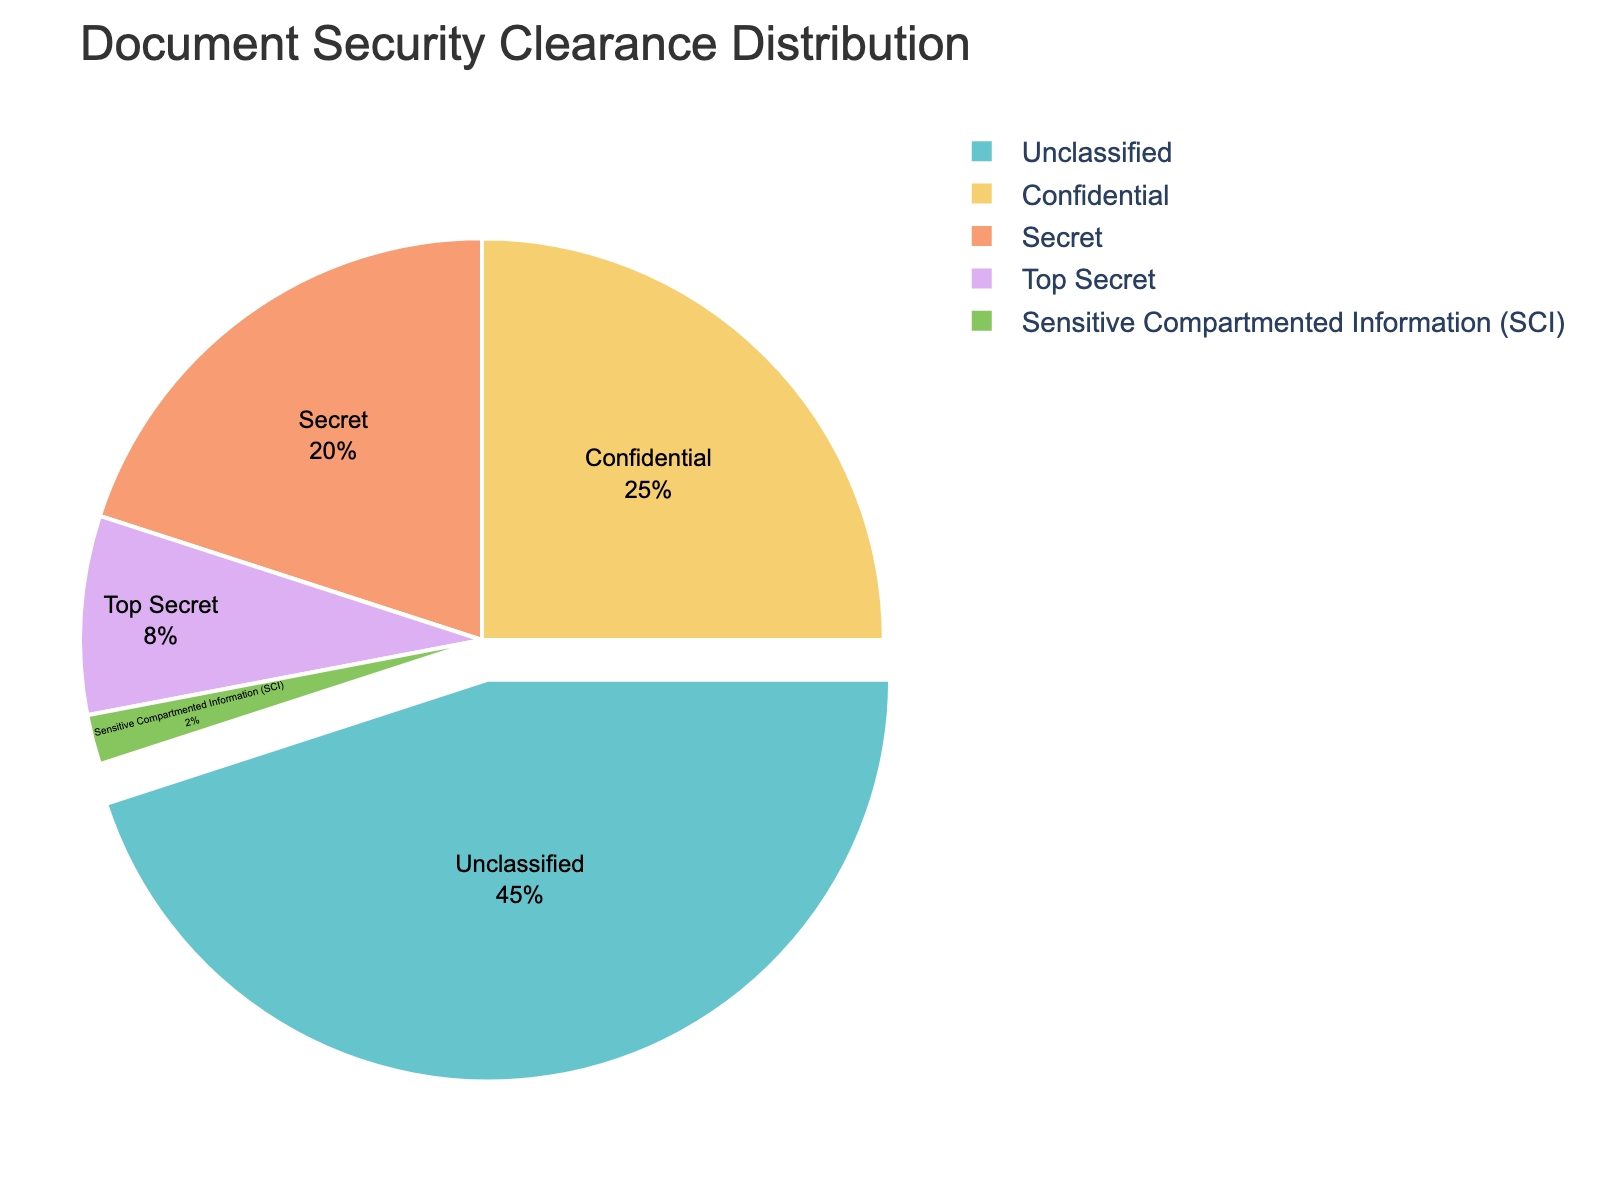What percentage of documents have a Confidential security clearance? The pie chart shows the division of documents by their security clearance levels. The segment labeled "Confidential" indicates the percentage.
Answer: 25% What is the combined percentage of documents that are Top Secret or have SCI clearance? To find the combined percentage, add the percentage of Top Secret documents to the percentage of SCI documents. According to the chart, Top Secret is 8% and SCI is 2%. Thus, the combined percentage is 8% + 2% = 10%.
Answer: 10% Which security clearance level has the largest share of documents? By observing the pie chart, the segment with the largest share corresponds to the "Unclassified" category.
Answer: Unclassified How does the percentage of Secret documents compare to that of Confidential documents? The pie chart shows that Secret documents account for 20% of the total, while Confidential documents account for 25%. Therefore, Secret documents have a lower percentage than Confidential documents.
Answer: Secret is less than Confidential What is the difference in percentage between Unclassified and Secret documents? According to the pie chart, Unclassified documents represent 45%, while Secret documents account for 20%. The difference is calculated as 45% - 20% = 25%.
Answer: 25% Are there any security clearance levels that require fewer than 5% of the documents? By examining the chart, we can see that the "Sensitive Compartmented Information (SCI)" category falls into this range with 2%.
Answer: Yes, SCI What is the total percentage of documents classified as either Confidential or Secret? To find the total, add the percentages of both categories. Confidential documents are 25%, and Secret documents are 20%. The total is 25% + 20% = 45%.
Answer: 45% Which security clearance level has the smallest proportion of documents, and what percentage does it represent? The smallest portion is represented by the "Sensitive Compartmented Information (SCI)" section, which is 2%.
Answer: Sensitive Compartmented Information (SCI), 2% Which category of documents would be most affected if the percentage of Unclassified documents decreased by 10% to 35%? If the percentage of Unclassified documents decreased by 10% to 35%, it would still remain the largest category as the next highest category, Confidential, is at 25%. Therefore, none of the other categories would surpass Unclassified.
Answer: None How many categories have a percentage greater than or equal to 20%? By looking at the pie chart, the categories that have percentages of 20% or more are Unclassified (45%), Confidential (25%), and Secret (20%), making a total of three categories.
Answer: Three 